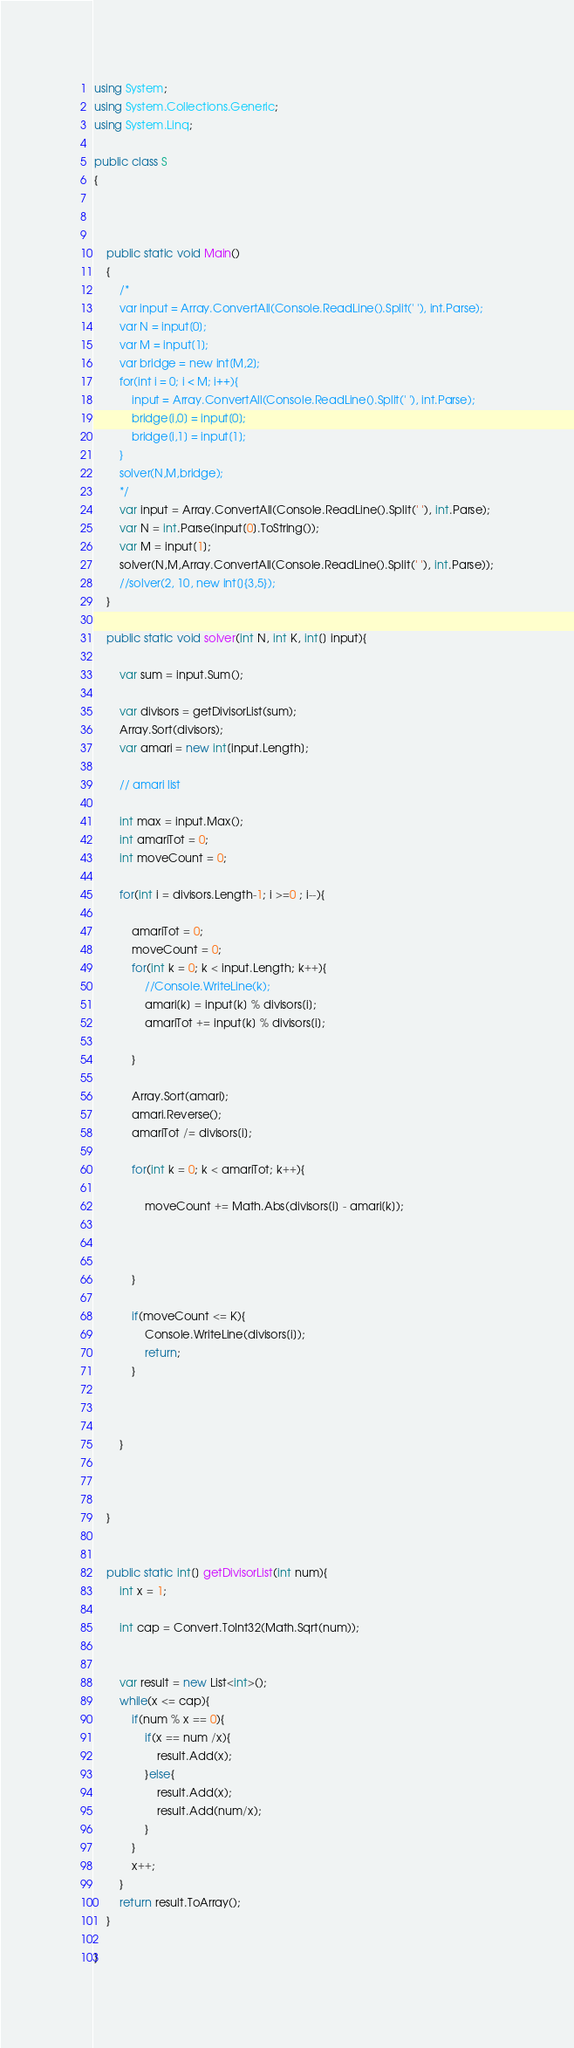Convert code to text. <code><loc_0><loc_0><loc_500><loc_500><_C#_>using System;
using System.Collections.Generic;
using System.Linq;

public class S
{



    public static void Main()
	{
		/*
        var input = Array.ConvertAll(Console.ReadLine().Split(' '), int.Parse);
        var N = input[0];
        var M = input[1];
        var bridge = new int[M,2];
        for(int i = 0; i < M; i++){
            input = Array.ConvertAll(Console.ReadLine().Split(' '), int.Parse);
            bridge[i,0] = input[0];
            bridge[i,1] = input[1];
        }
        solver(N,M,bridge);
		*/
		var input = Array.ConvertAll(Console.ReadLine().Split(' '), int.Parse);
        var N = int.Parse(input[0].ToString());
        var M = input[1];
		solver(N,M,Array.ConvertAll(Console.ReadLine().Split(' '), int.Parse));
        //solver(2, 10, new int[]{3,5});
    }

    public static void solver(int N, int K, int[] input){

        var sum = input.Sum();

        var divisors = getDivisorList(sum);
        Array.Sort(divisors);
        var amari = new int[input.Length];

        // amari list

        int max = input.Max();
        int amariTot = 0;
        int moveCount = 0;

        for(int i = divisors.Length-1; i >=0 ; i--){

            amariTot = 0;
            moveCount = 0;
            for(int k = 0; k < input.Length; k++){
				//Console.WriteLine(k);
                amari[k] = input[k] % divisors[i];
                amariTot += input[k] % divisors[i];

            }

            Array.Sort(amari);
            amari.Reverse();
            amariTot /= divisors[i];

            for(int k = 0; k < amariTot; k++){
                
                moveCount += Math.Abs(divisors[i] - amari[k]);

                
                
            }
			
            if(moveCount <= K){
                Console.WriteLine(divisors[i]);
                return;
            }
			
			

        }



    }


    public static int[] getDivisorList(int num){
        int x = 1;

        int cap = Convert.ToInt32(Math.Sqrt(num));


        var result = new List<int>();
        while(x <= cap){
            if(num % x == 0){
                if(x == num /x){
                    result.Add(x);
                }else{
                    result.Add(x);
                    result.Add(num/x);
                }
            } 
            x++;
        }
		return result.ToArray();
    }

}</code> 